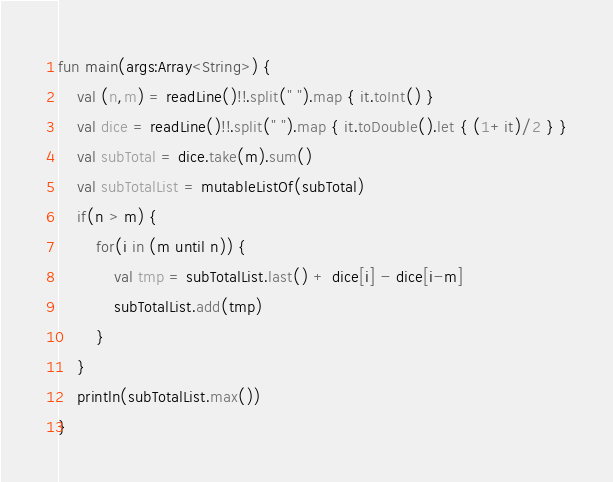<code> <loc_0><loc_0><loc_500><loc_500><_Kotlin_>fun main(args:Array<String>) {
    val (n,m) = readLine()!!.split(" ").map { it.toInt() }
    val dice = readLine()!!.split(" ").map { it.toDouble().let { (1+it)/2 } }
    val subTotal = dice.take(m).sum()
    val subTotalList = mutableListOf(subTotal)
    if(n > m) {
        for(i in (m until n)) {
            val tmp = subTotalList.last() + dice[i] - dice[i-m]
            subTotalList.add(tmp)
        }
    }
    println(subTotalList.max())
}
</code> 